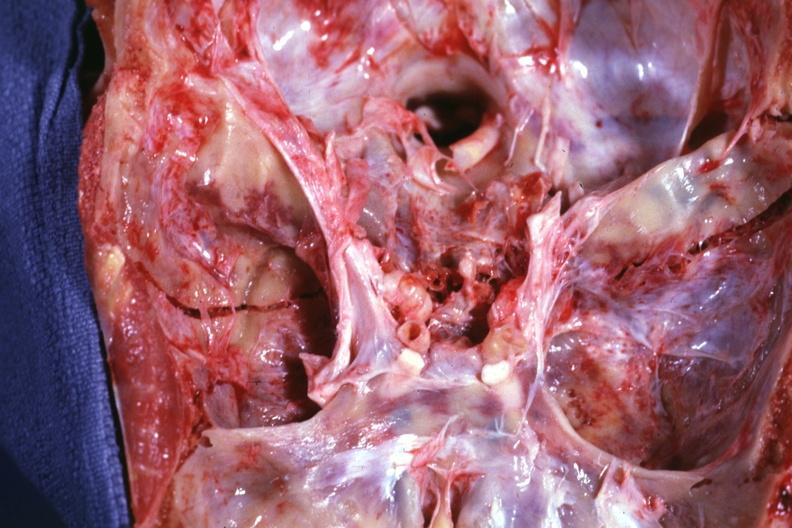does this image show good close-up?
Answer the question using a single word or phrase. Yes 